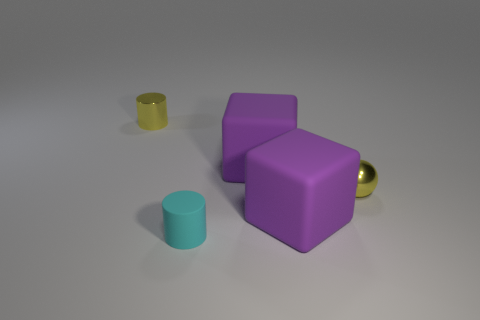What material is the tiny yellow thing right of the cylinder to the right of the cylinder to the left of the tiny matte thing made of?
Make the answer very short. Metal. Is the number of metallic balls to the left of the tiny matte object greater than the number of small rubber things on the right side of the small yellow ball?
Your response must be concise. No. What number of rubber things are spheres or cyan things?
Provide a succinct answer. 1. There is a small thing that is the same color as the small sphere; what is its shape?
Keep it short and to the point. Cylinder. There is a small yellow cylinder on the left side of the small cyan object; what material is it?
Ensure brevity in your answer.  Metal. How many things are either metal spheres or tiny metallic things to the left of the cyan rubber thing?
Provide a succinct answer. 2. What is the shape of the cyan thing that is the same size as the yellow sphere?
Make the answer very short. Cylinder. How many objects are the same color as the metal cylinder?
Keep it short and to the point. 1. Is the material of the cyan cylinder that is in front of the yellow sphere the same as the small yellow cylinder?
Your response must be concise. No. There is a tiny matte object; what shape is it?
Your answer should be very brief. Cylinder. 